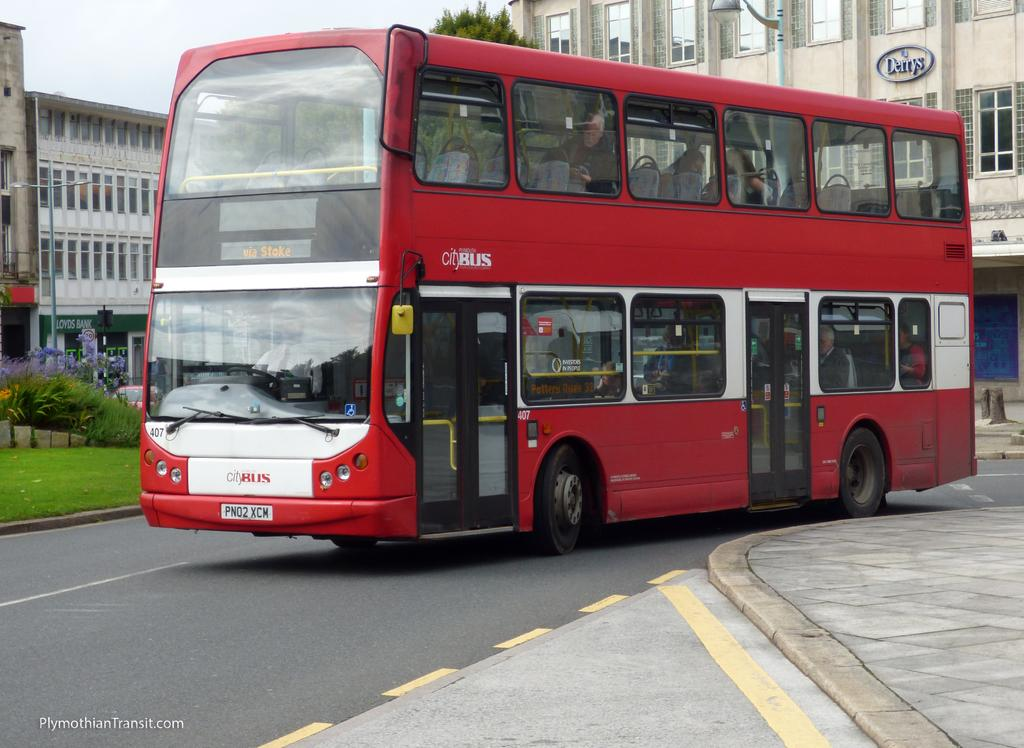What type of vehicle is on the road in the image? There is a red bus on the road in the image. What can be seen on the left side of the image? There is a garden with plants on the left side of the image. What is visible in the background of the image? There are buildings in the background of the image. What part of the natural environment is visible in the image? The sky is visible above the buildings. What type of memory does the kitty have in the image? There is no kitty present in the image, so it is not possible to determine what type of memory it might have. 